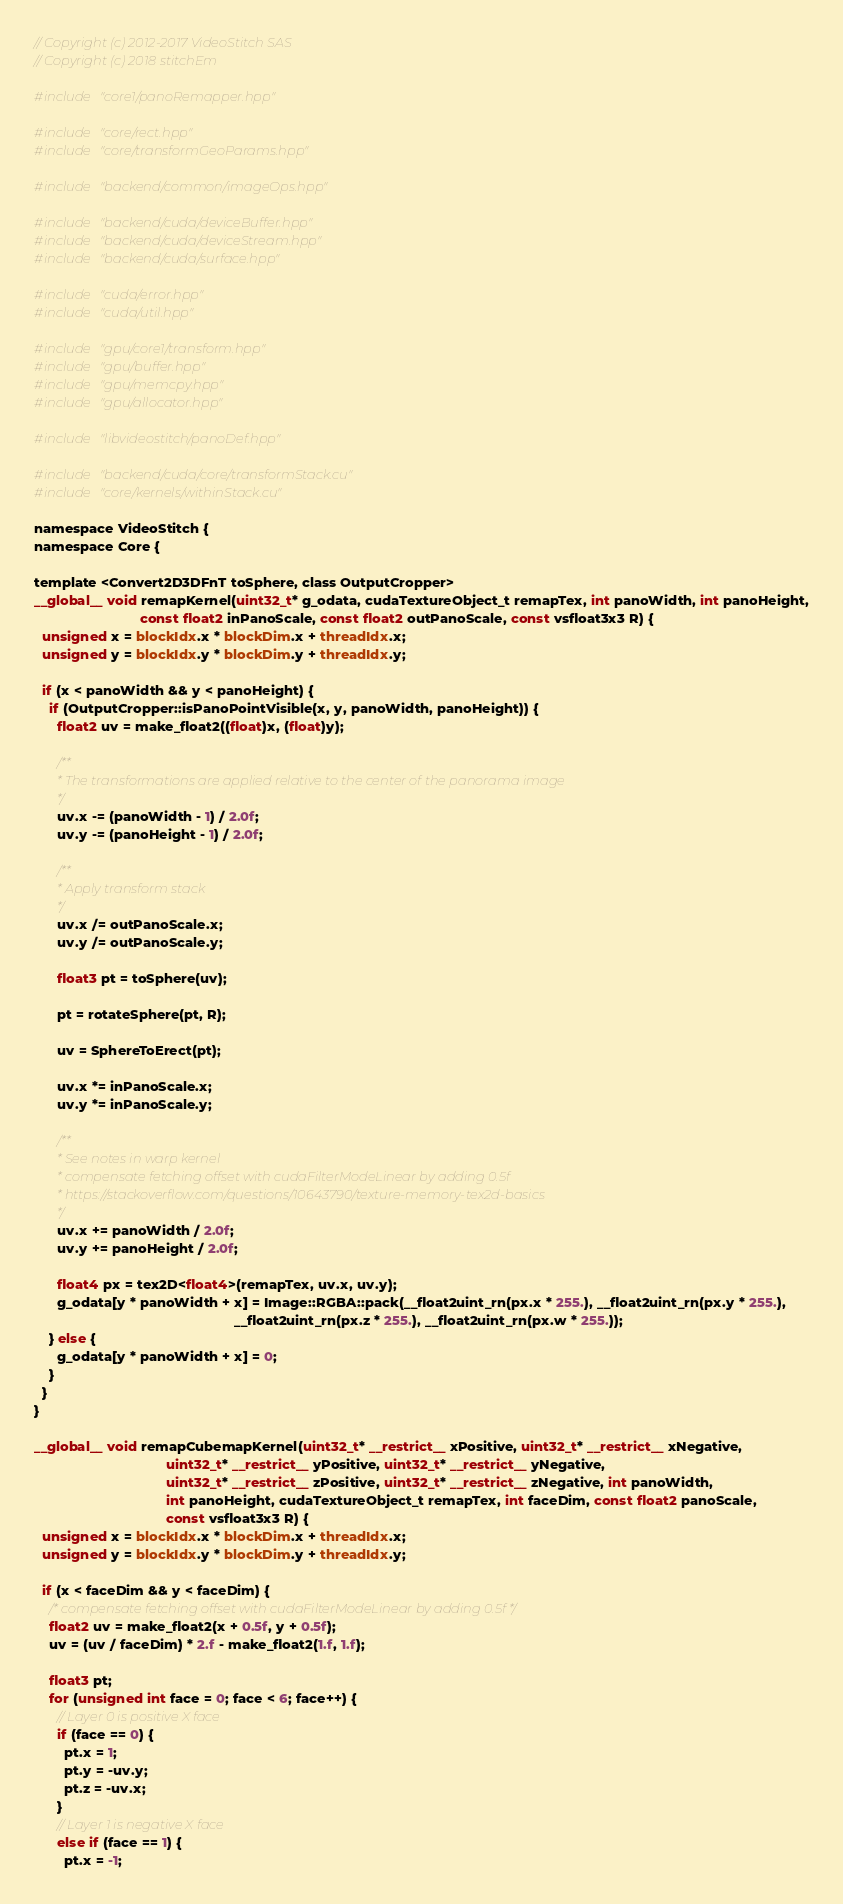<code> <loc_0><loc_0><loc_500><loc_500><_Cuda_>// Copyright (c) 2012-2017 VideoStitch SAS
// Copyright (c) 2018 stitchEm

#include "core1/panoRemapper.hpp"

#include "core/rect.hpp"
#include "core/transformGeoParams.hpp"

#include "backend/common/imageOps.hpp"

#include "backend/cuda/deviceBuffer.hpp"
#include "backend/cuda/deviceStream.hpp"
#include "backend/cuda/surface.hpp"

#include "cuda/error.hpp"
#include "cuda/util.hpp"

#include "gpu/core1/transform.hpp"
#include "gpu/buffer.hpp"
#include "gpu/memcpy.hpp"
#include "gpu/allocator.hpp"

#include "libvideostitch/panoDef.hpp"

#include "backend/cuda/core/transformStack.cu"
#include "core/kernels/withinStack.cu"

namespace VideoStitch {
namespace Core {

template <Convert2D3DFnT toSphere, class OutputCropper>
__global__ void remapKernel(uint32_t* g_odata, cudaTextureObject_t remapTex, int panoWidth, int panoHeight,
                            const float2 inPanoScale, const float2 outPanoScale, const vsfloat3x3 R) {
  unsigned x = blockIdx.x * blockDim.x + threadIdx.x;
  unsigned y = blockIdx.y * blockDim.y + threadIdx.y;

  if (x < panoWidth && y < panoHeight) {
    if (OutputCropper::isPanoPointVisible(x, y, panoWidth, panoHeight)) {
      float2 uv = make_float2((float)x, (float)y);

      /**
       * The transformations are applied relative to the center of the panorama image
       */
      uv.x -= (panoWidth - 1) / 2.0f;
      uv.y -= (panoHeight - 1) / 2.0f;

      /**
       * Apply transform stack
       */
      uv.x /= outPanoScale.x;
      uv.y /= outPanoScale.y;

      float3 pt = toSphere(uv);

      pt = rotateSphere(pt, R);

      uv = SphereToErect(pt);

      uv.x *= inPanoScale.x;
      uv.y *= inPanoScale.y;

      /**
       * See notes in warp kernel
       * compensate fetching offset with cudaFilterModeLinear by adding 0.5f
       * https://stackoverflow.com/questions/10643790/texture-memory-tex2d-basics
       */
      uv.x += panoWidth / 2.0f;
      uv.y += panoHeight / 2.0f;

      float4 px = tex2D<float4>(remapTex, uv.x, uv.y);
      g_odata[y * panoWidth + x] = Image::RGBA::pack(__float2uint_rn(px.x * 255.), __float2uint_rn(px.y * 255.),
                                                     __float2uint_rn(px.z * 255.), __float2uint_rn(px.w * 255.));
    } else {
      g_odata[y * panoWidth + x] = 0;
    }
  }
}

__global__ void remapCubemapKernel(uint32_t* __restrict__ xPositive, uint32_t* __restrict__ xNegative,
                                   uint32_t* __restrict__ yPositive, uint32_t* __restrict__ yNegative,
                                   uint32_t* __restrict__ zPositive, uint32_t* __restrict__ zNegative, int panoWidth,
                                   int panoHeight, cudaTextureObject_t remapTex, int faceDim, const float2 panoScale,
                                   const vsfloat3x3 R) {
  unsigned x = blockIdx.x * blockDim.x + threadIdx.x;
  unsigned y = blockIdx.y * blockDim.y + threadIdx.y;

  if (x < faceDim && y < faceDim) {
    /* compensate fetching offset with cudaFilterModeLinear by adding 0.5f */
    float2 uv = make_float2(x + 0.5f, y + 0.5f);
    uv = (uv / faceDim) * 2.f - make_float2(1.f, 1.f);

    float3 pt;
    for (unsigned int face = 0; face < 6; face++) {
      // Layer 0 is positive X face
      if (face == 0) {
        pt.x = 1;
        pt.y = -uv.y;
        pt.z = -uv.x;
      }
      // Layer 1 is negative X face
      else if (face == 1) {
        pt.x = -1;</code> 